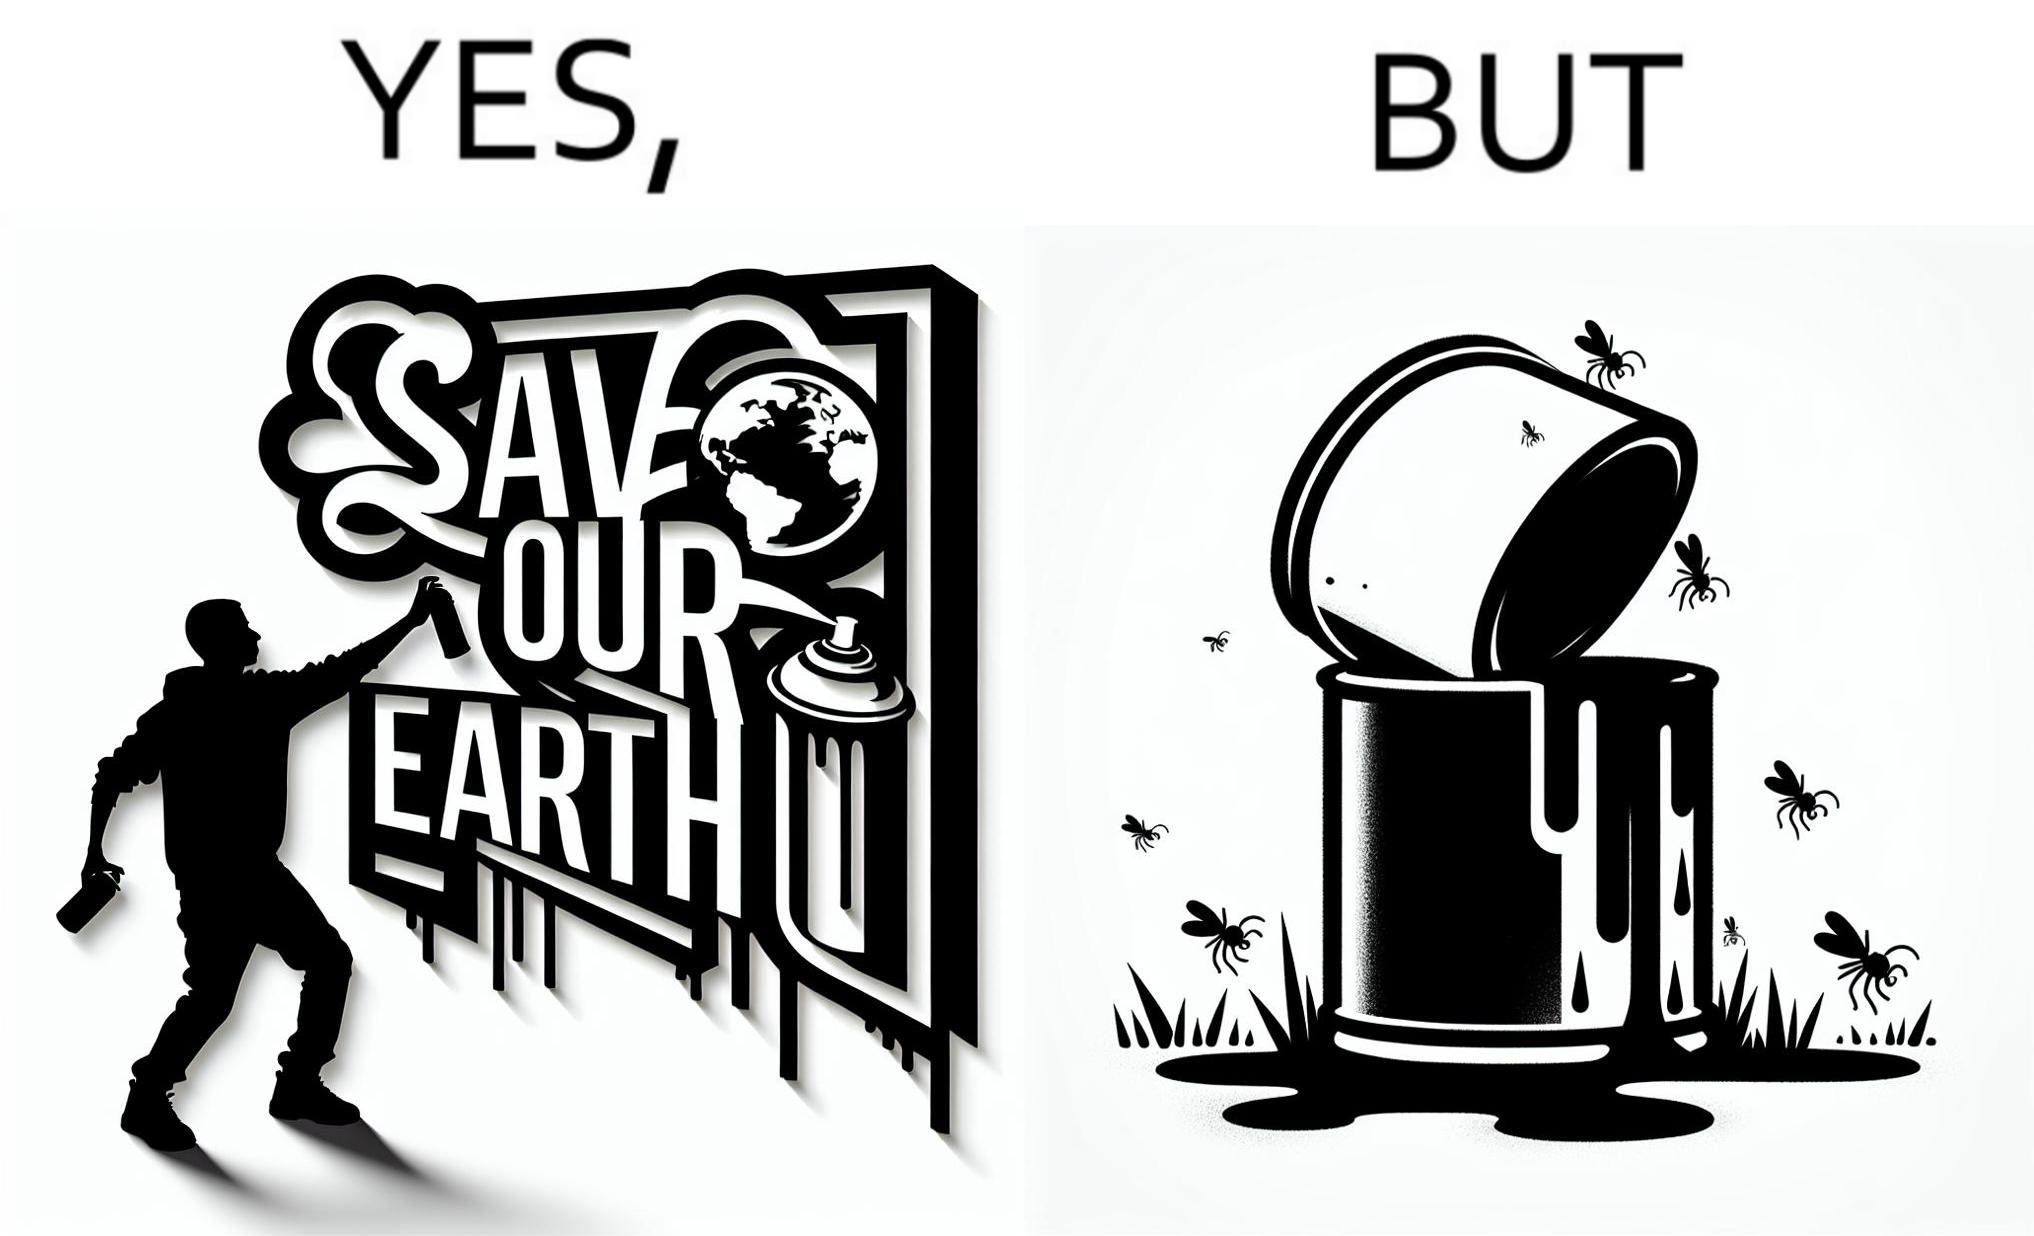What is shown in the left half versus the right half of this image? In the left part of the image: A man drawing a graffiti themed "save Our earth". In the right part of the image: A can of paint, overflowing onto the grass. The paint seems to be harmful for insects. 